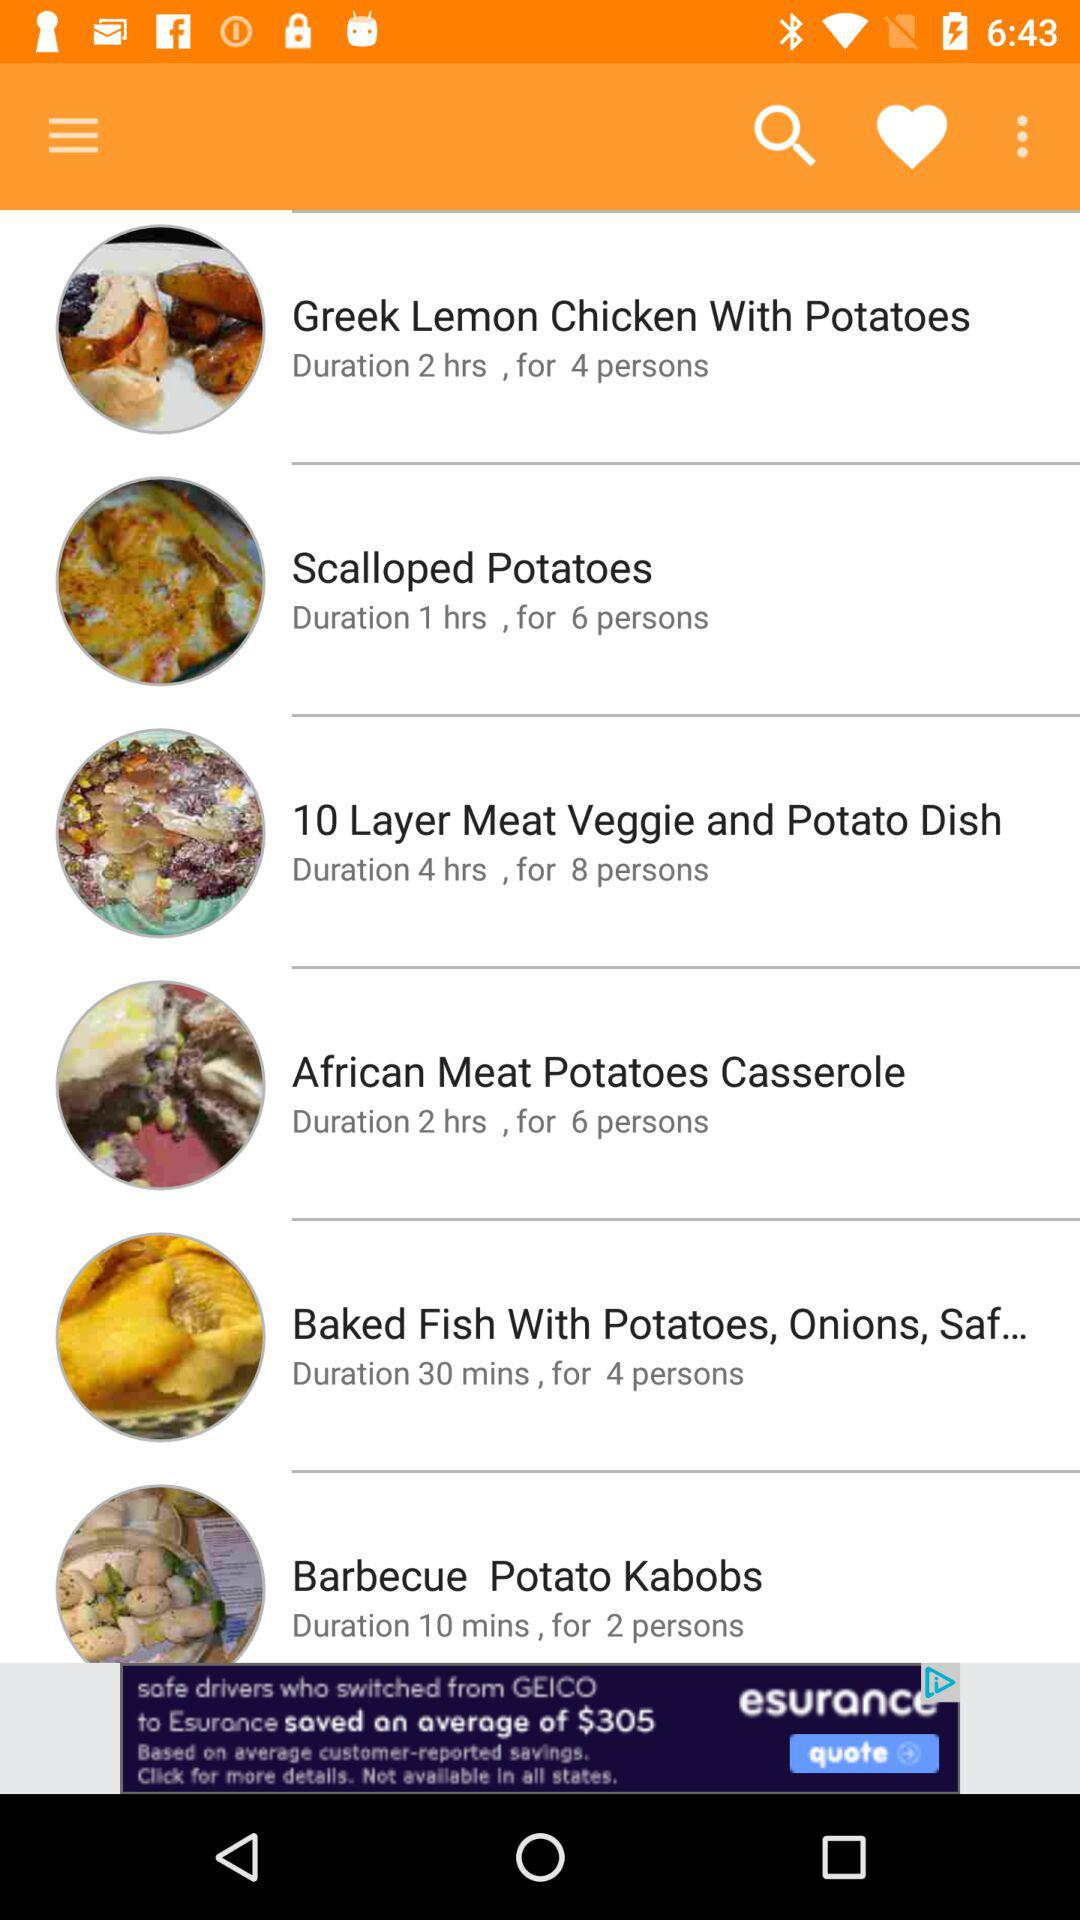How many people required to prepare barbecue potato kabobs?
When the provided information is insufficient, respond with <no answer>. <no answer> 